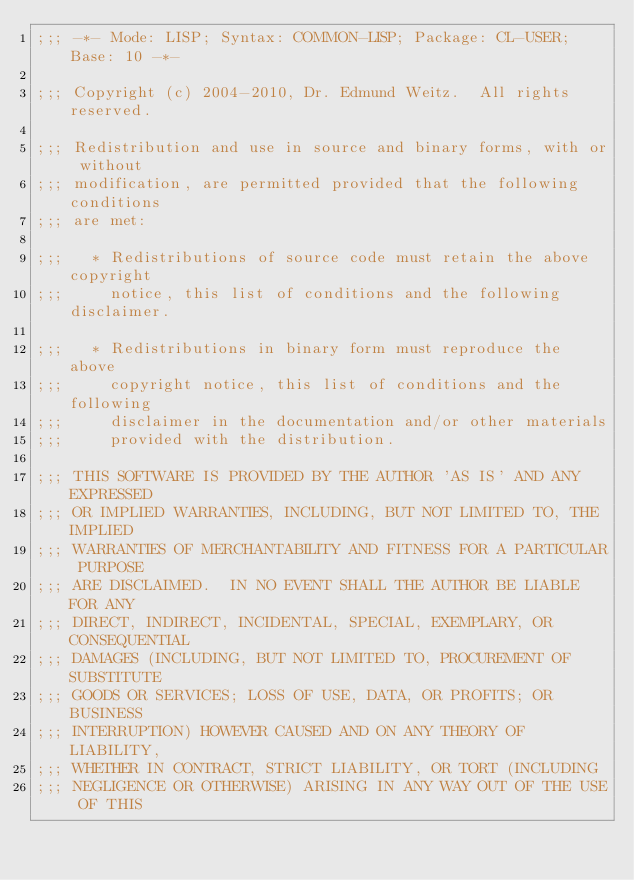Convert code to text. <code><loc_0><loc_0><loc_500><loc_500><_Lisp_>;;; -*- Mode: LISP; Syntax: COMMON-LISP; Package: CL-USER; Base: 10 -*-

;;; Copyright (c) 2004-2010, Dr. Edmund Weitz.  All rights reserved.

;;; Redistribution and use in source and binary forms, with or without
;;; modification, are permitted provided that the following conditions
;;; are met:

;;;   * Redistributions of source code must retain the above copyright
;;;     notice, this list of conditions and the following disclaimer.

;;;   * Redistributions in binary form must reproduce the above
;;;     copyright notice, this list of conditions and the following
;;;     disclaimer in the documentation and/or other materials
;;;     provided with the distribution.

;;; THIS SOFTWARE IS PROVIDED BY THE AUTHOR 'AS IS' AND ANY EXPRESSED
;;; OR IMPLIED WARRANTIES, INCLUDING, BUT NOT LIMITED TO, THE IMPLIED
;;; WARRANTIES OF MERCHANTABILITY AND FITNESS FOR A PARTICULAR PURPOSE
;;; ARE DISCLAIMED.  IN NO EVENT SHALL THE AUTHOR BE LIABLE FOR ANY
;;; DIRECT, INDIRECT, INCIDENTAL, SPECIAL, EXEMPLARY, OR CONSEQUENTIAL
;;; DAMAGES (INCLUDING, BUT NOT LIMITED TO, PROCUREMENT OF SUBSTITUTE
;;; GOODS OR SERVICES; LOSS OF USE, DATA, OR PROFITS; OR BUSINESS
;;; INTERRUPTION) HOWEVER CAUSED AND ON ANY THEORY OF LIABILITY,
;;; WHETHER IN CONTRACT, STRICT LIABILITY, OR TORT (INCLUDING
;;; NEGLIGENCE OR OTHERWISE) ARISING IN ANY WAY OUT OF THE USE OF THIS</code> 